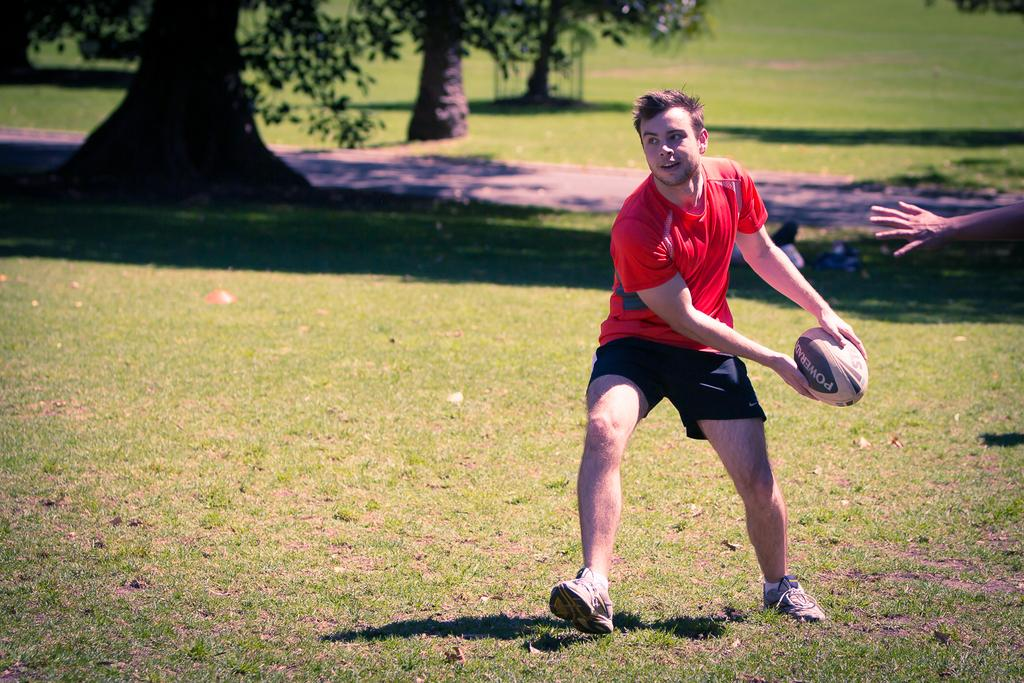What is the person in the image doing? The person is standing on the grass. What is the person holding in his hand? The person is holding a ball in his hand. What color is the t-shirt the person is wearing? The person is wearing a red t-shirt. What type of clothing is the person wearing on his lower body? The person is wearing shorts. Can you describe the hand visible at the right side of the image? There is a hand of a person visible at the right side of the image. What can be seen in the background behind the person? There are trees behind the person. What type of kitty can be seen playing with the camera in the image? There is no kitty or camera present in the image. 